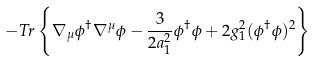<formula> <loc_0><loc_0><loc_500><loc_500>\, - T r \left \{ \nabla _ { \mu } \phi ^ { \dag } \nabla ^ { \mu } \phi - \frac { 3 } { 2 a _ { 1 } ^ { 2 } } \phi ^ { \dag } \phi + 2 g _ { 1 } ^ { 2 } ( \phi ^ { \dag } \phi ) ^ { 2 } \right \}</formula> 